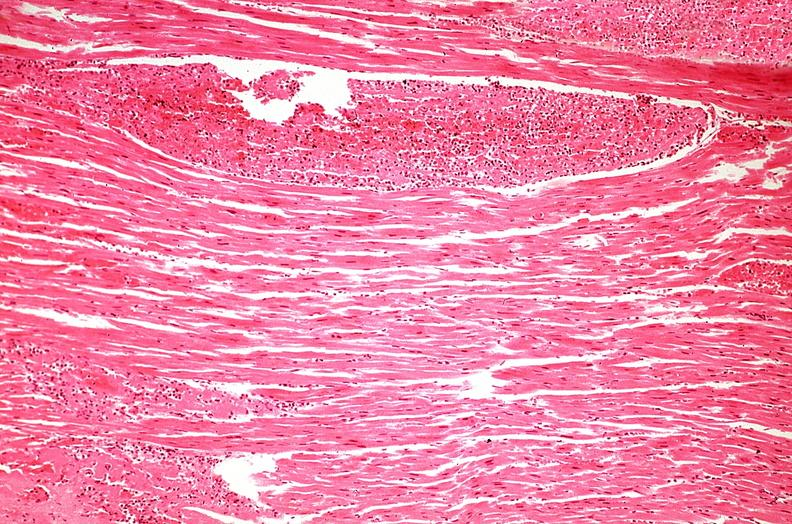what does this image show?
Answer the question using a single word or phrase. Heart 